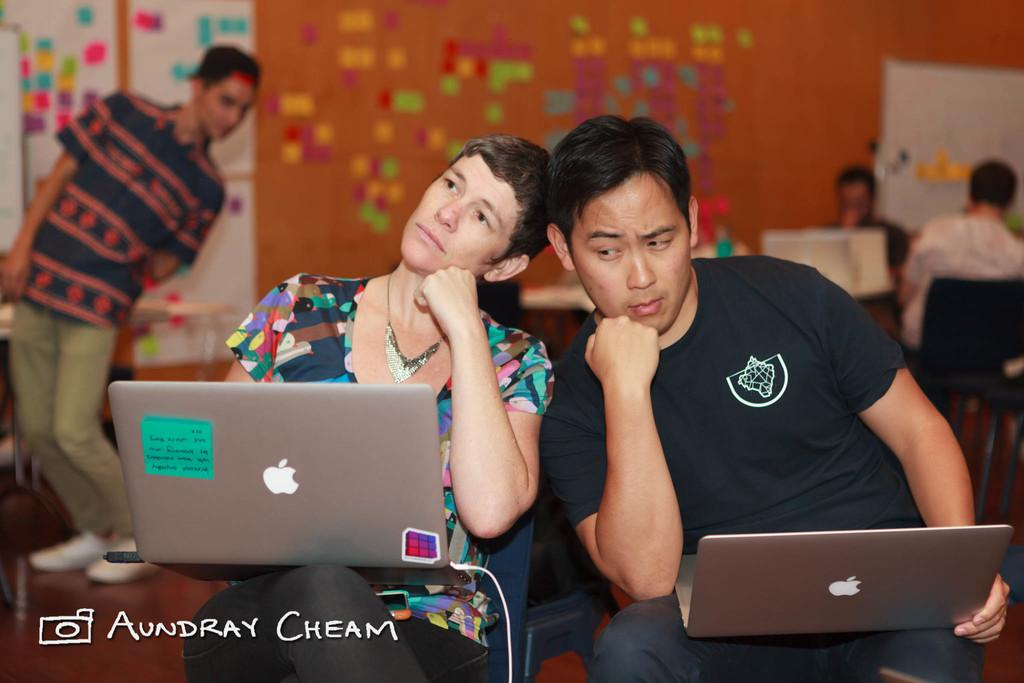How many people are sitting on chairs in the image? There are two persons sitting on chairs in the image. What are the persons holding while sitting on the chairs? The persons are holding laptops. Where is the scene set? The scene is set on a floor. Are there any other people present in the image? Yes, there are other persons present in the image. What can be seen in the background of the image? There is a board and a wall visible in the background. What type of land can be seen in the image? There is no land visible in the image, as the scene is set indoors on a floor. What is the reaction of the persons to the scent in the image? There is no mention of a scent in the image, so it is not possible to determine the reaction of the persons to it. 